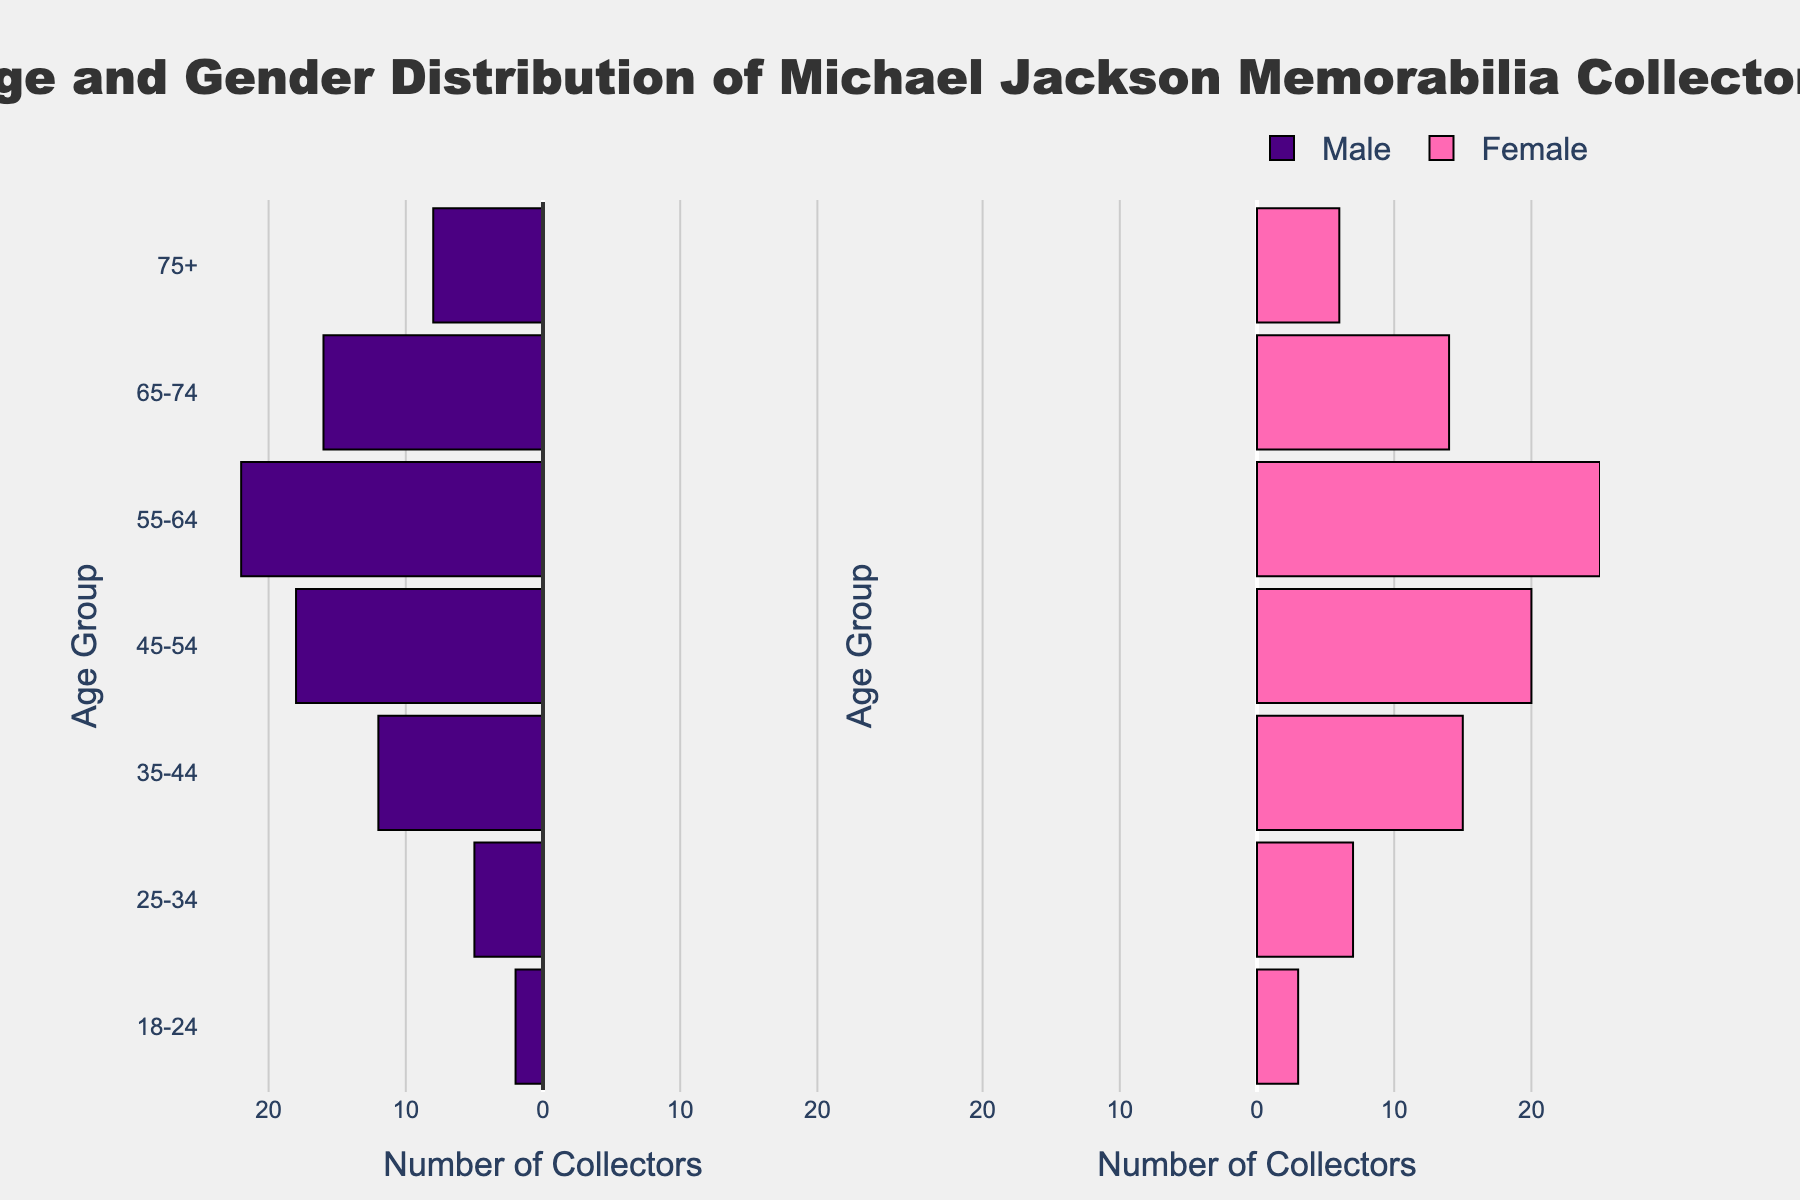What's the title of the figure? The title is usually displayed at the top of the figure and summarizes the content. In this case, it's clearly shown as "Age and Gender Distribution of Michael Jackson Memorabilia Collectors."
Answer: Age and Gender Distribution of Michael Jackson Memorabilia Collectors What age group has the highest number of male collectors? To find this, look at the bars on the left side representing male collectors. The age group with the longest bar is 55-64.
Answer: 55-64 Which age group has more female collectors than male collectors? Compare the lengths of the bars on the right side (female) to the bars on the left side (male) for each age group. The age groups 18-24, 25-34, 35-44, 45-54, and 55-64 have more female collectors than male.
Answer: 18-24, 25-34, 35-44, 45-54, 55-64 What is the total number of collectors in the 45-54 age group? Sum the male and female collectors in the 45-54 age group: 18 (male) + 20 (female) = 38.
Answer: 38 Which gender has the most collectors in the 75+ age group? Compare the lengths of the bars for males and females in the 75+ age group. There are more male collectors (8) than female collectors (6).
Answer: Male What is the difference between the number of male and female collectors in the 35-44 age group? Subtract the number of male collectors from the number of female collectors in that age group: 15 (female) - 12 (male) = 3.
Answer: 3 How many total collectors are there in the 65-74 age group? Add the number of male and female collectors in the 65-74 age group: 16 (male) + 14 (female) = 30.
Answer: 30 Which age group has the most significant number of female collectors? Look at the bars on the right side (female) and identify the longest one. The 55-64 age group has the most female collectors with 25.
Answer: 55-64 In which age groups do male collectors outnumber female collectors? Compare the lengths of the bars for males and females in each age group. The age groups 65-74 and 75+ have more male collectors than female collectors.
Answer: 65-74, 75+ 